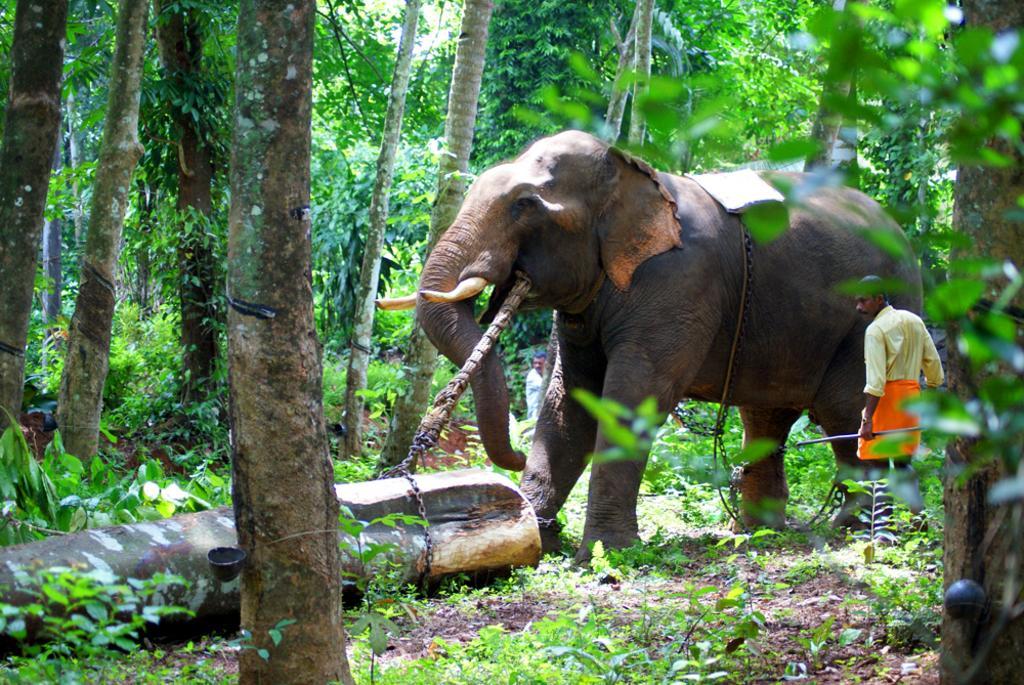Can you describe this image briefly? In this picture I can see an elephant holding a stick, there are two person's, a person holding a stick, there is a tree trunk with a chain, there are plants, and in the background there are trees. 